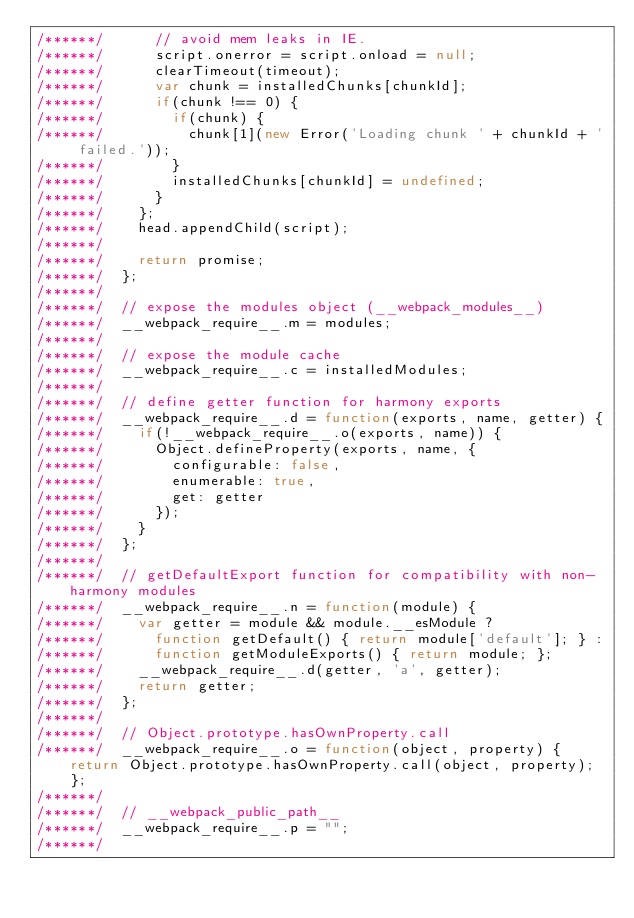<code> <loc_0><loc_0><loc_500><loc_500><_JavaScript_>/******/ 			// avoid mem leaks in IE.
/******/ 			script.onerror = script.onload = null;
/******/ 			clearTimeout(timeout);
/******/ 			var chunk = installedChunks[chunkId];
/******/ 			if(chunk !== 0) {
/******/ 				if(chunk) {
/******/ 					chunk[1](new Error('Loading chunk ' + chunkId + ' failed.'));
/******/ 				}
/******/ 				installedChunks[chunkId] = undefined;
/******/ 			}
/******/ 		};
/******/ 		head.appendChild(script);
/******/
/******/ 		return promise;
/******/ 	};
/******/
/******/ 	// expose the modules object (__webpack_modules__)
/******/ 	__webpack_require__.m = modules;
/******/
/******/ 	// expose the module cache
/******/ 	__webpack_require__.c = installedModules;
/******/
/******/ 	// define getter function for harmony exports
/******/ 	__webpack_require__.d = function(exports, name, getter) {
/******/ 		if(!__webpack_require__.o(exports, name)) {
/******/ 			Object.defineProperty(exports, name, {
/******/ 				configurable: false,
/******/ 				enumerable: true,
/******/ 				get: getter
/******/ 			});
/******/ 		}
/******/ 	};
/******/
/******/ 	// getDefaultExport function for compatibility with non-harmony modules
/******/ 	__webpack_require__.n = function(module) {
/******/ 		var getter = module && module.__esModule ?
/******/ 			function getDefault() { return module['default']; } :
/******/ 			function getModuleExports() { return module; };
/******/ 		__webpack_require__.d(getter, 'a', getter);
/******/ 		return getter;
/******/ 	};
/******/
/******/ 	// Object.prototype.hasOwnProperty.call
/******/ 	__webpack_require__.o = function(object, property) { return Object.prototype.hasOwnProperty.call(object, property); };
/******/
/******/ 	// __webpack_public_path__
/******/ 	__webpack_require__.p = "";
/******/</code> 